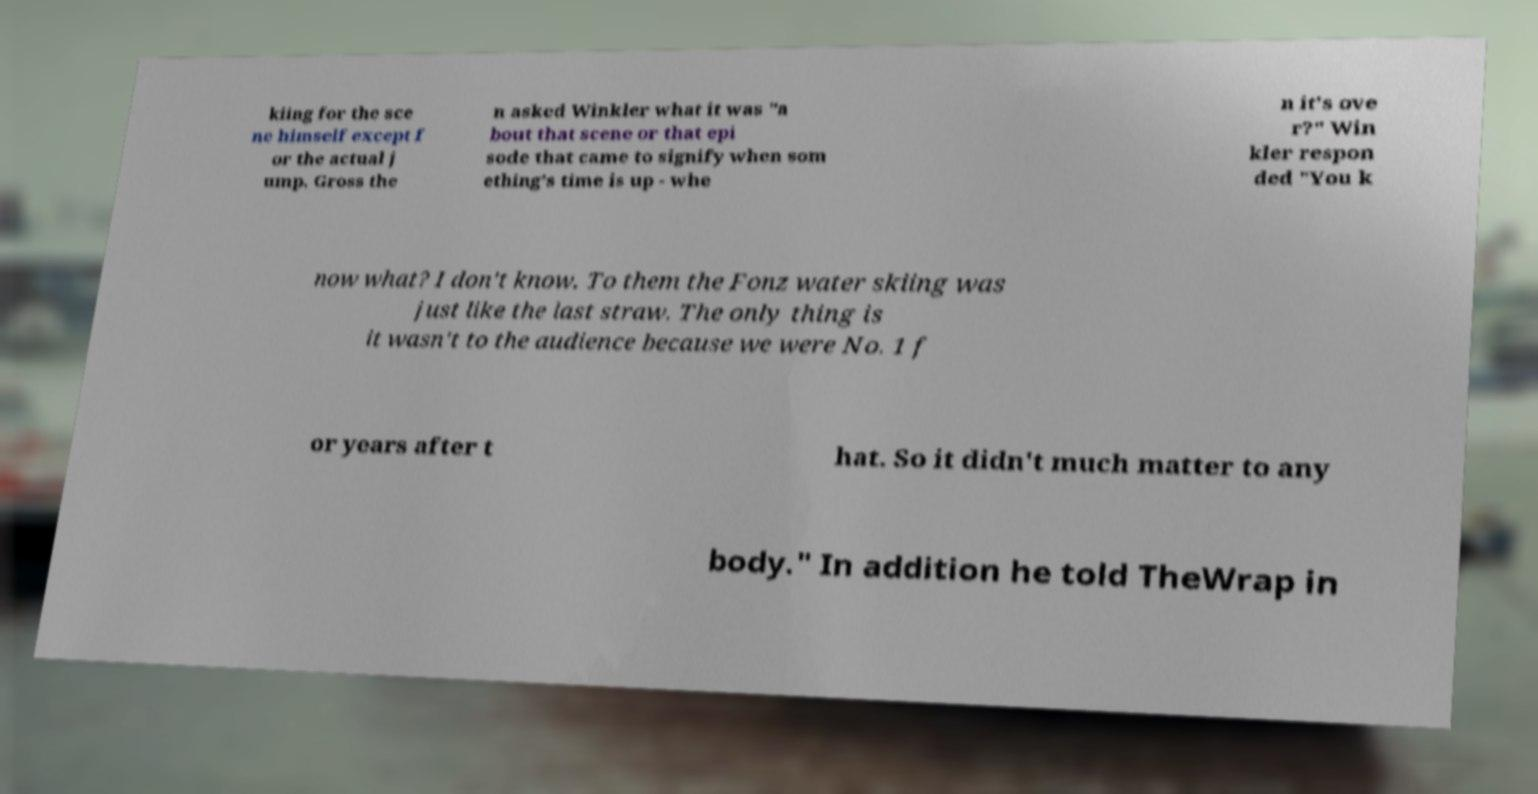For documentation purposes, I need the text within this image transcribed. Could you provide that? kiing for the sce ne himself except f or the actual j ump. Gross the n asked Winkler what it was "a bout that scene or that epi sode that came to signify when som ething's time is up - whe n it's ove r?" Win kler respon ded "You k now what? I don't know. To them the Fonz water skiing was just like the last straw. The only thing is it wasn't to the audience because we were No. 1 f or years after t hat. So it didn't much matter to any body." In addition he told TheWrap in 